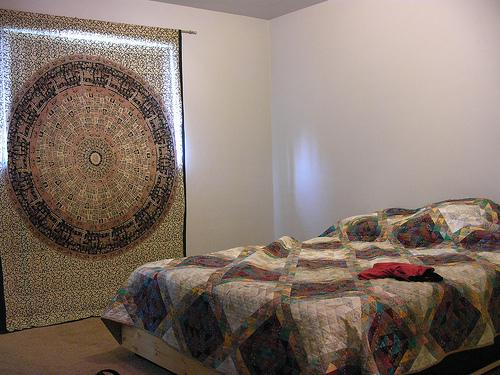Question: what is the main object in the photo?
Choices:
A. Cat.
B. Bed.
C. Statue.
D. Motorcycle.
Answer with the letter. Answer: B Question: where is the shirt?
Choices:
A. On the bed.
B. On the boy.
C. On a clothes line.
D. On the floor.
Answer with the letter. Answer: A Question: where was this photo taken?
Choices:
A. Bathroom.
B. In a bedroom.
C. Kitchen.
D. Den.
Answer with the letter. Answer: B 